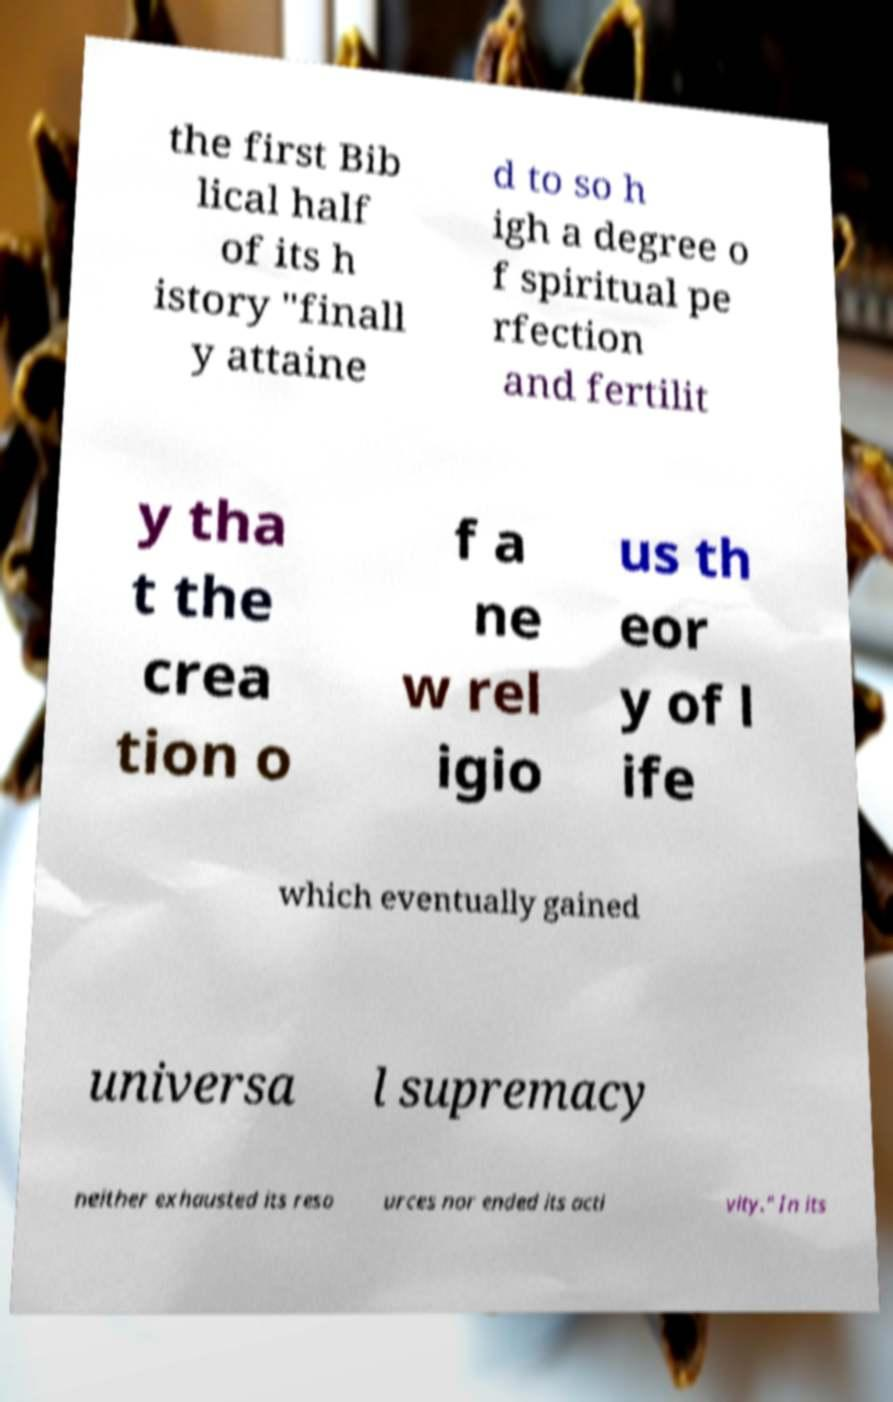Can you read and provide the text displayed in the image?This photo seems to have some interesting text. Can you extract and type it out for me? the first Bib lical half of its h istory "finall y attaine d to so h igh a degree o f spiritual pe rfection and fertilit y tha t the crea tion o f a ne w rel igio us th eor y of l ife which eventually gained universa l supremacy neither exhausted its reso urces nor ended its acti vity." In its 